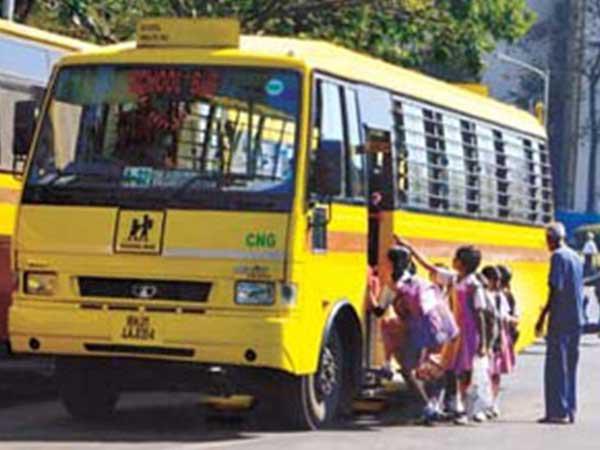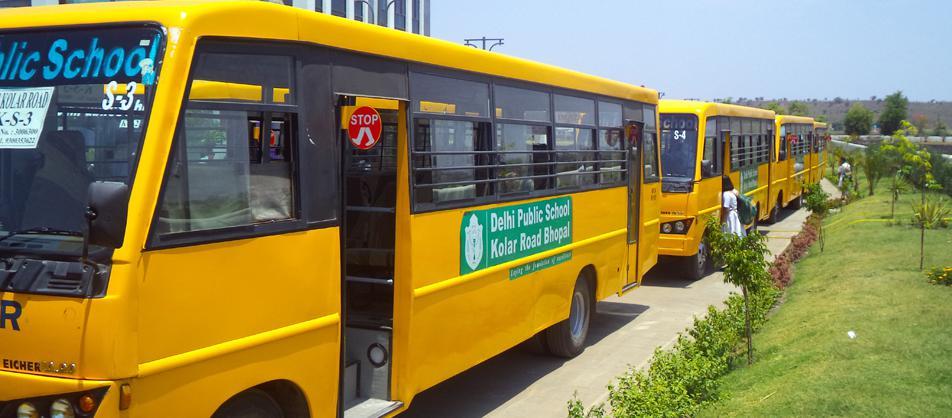The first image is the image on the left, the second image is the image on the right. For the images displayed, is the sentence "At least one bus is not crashed." factually correct? Answer yes or no. Yes. The first image is the image on the left, the second image is the image on the right. Given the left and right images, does the statement "The left and right image contains the same number of  yellow buses." hold true? Answer yes or no. No. 